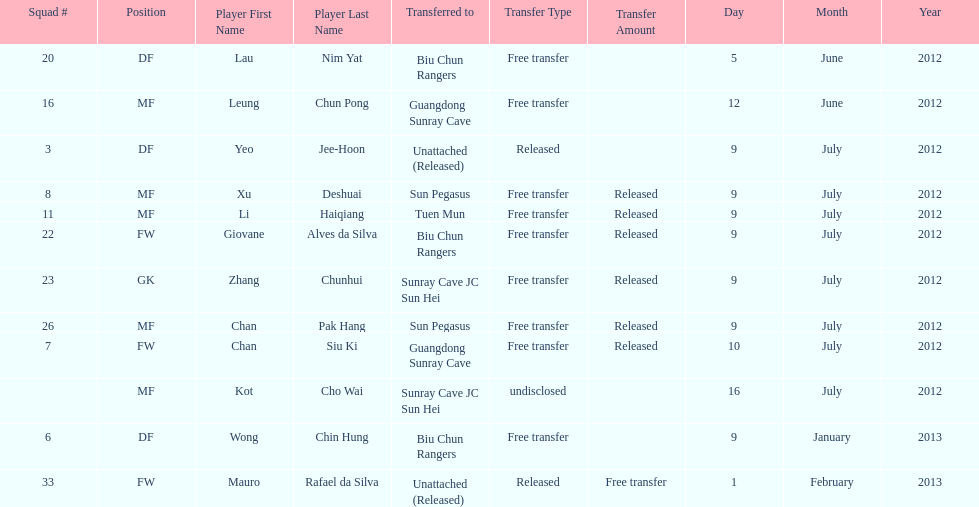Would you mind parsing the complete table? {'header': ['Squad #', 'Position', 'Player First Name', 'Player Last Name', 'Transferred to', 'Transfer Type', 'Transfer Amount', 'Day', 'Month', 'Year'], 'rows': [['20', 'DF', 'Lau', 'Nim Yat', 'Biu Chun Rangers', 'Free transfer', '', '5', 'June', '2012'], ['16', 'MF', 'Leung', 'Chun Pong', 'Guangdong Sunray Cave', 'Free transfer', '', '12', 'June', '2012'], ['3', 'DF', 'Yeo', 'Jee-Hoon', 'Unattached (Released)', 'Released', '', '9', 'July', '2012'], ['8', 'MF', 'Xu', 'Deshuai', 'Sun Pegasus', 'Free transfer', 'Released', '9', 'July', '2012'], ['11', 'MF', 'Li', 'Haiqiang', 'Tuen Mun', 'Free transfer', 'Released', '9', 'July', '2012'], ['22', 'FW', 'Giovane', 'Alves da Silva', 'Biu Chun Rangers', 'Free transfer', 'Released', '9', 'July', '2012'], ['23', 'GK', 'Zhang', 'Chunhui', 'Sunray Cave JC Sun Hei', 'Free transfer', 'Released', '9', 'July', '2012'], ['26', 'MF', 'Chan', 'Pak Hang', 'Sun Pegasus', 'Free transfer', 'Released', '9', 'July', '2012'], ['7', 'FW', 'Chan', 'Siu Ki', 'Guangdong Sunray Cave', 'Free transfer', 'Released', '10', 'July', '2012'], ['', 'MF', 'Kot', 'Cho Wai', 'Sunray Cave JC Sun Hei', 'undisclosed', '', '16', 'July', '2012'], ['6', 'DF', 'Wong', 'Chin Hung', 'Biu Chun Rangers', 'Free transfer', '', '9', 'January', '2013'], ['33', 'FW', 'Mauro', 'Rafael da Silva', 'Unattached (Released)', 'Released', 'Free transfer', '1', 'February', '2013']]} Who is the first player listed? Lau Nim Yat. 